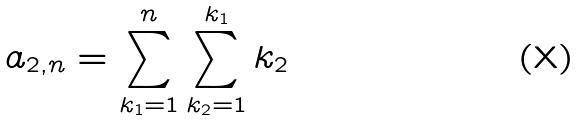Convert formula to latex. <formula><loc_0><loc_0><loc_500><loc_500>a _ { 2 , n } = \sum _ { k _ { 1 } = 1 } ^ { n } \sum _ { k _ { 2 } = 1 } ^ { k _ { 1 } } k _ { 2 }</formula> 